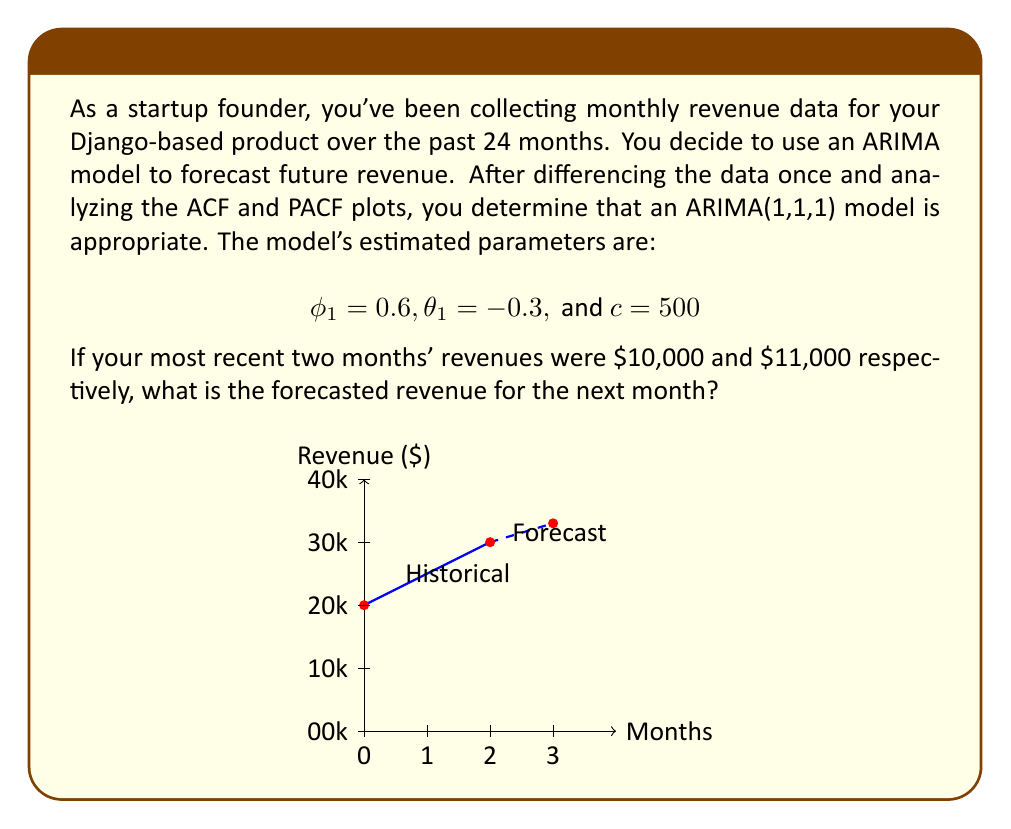Teach me how to tackle this problem. Let's approach this step-by-step:

1) The general form of an ARIMA(1,1,1) model is:

   $$(1-\phi_1B)(1-B)y_t = c + (1+\theta_1B)\epsilon_t$$

   where $B$ is the backshift operator.

2) Expanding this, we get:

   $$y_t - y_{t-1} = c + \phi_1(y_{t-1} - y_{t-2}) + \epsilon_t + \theta_1\epsilon_{t-1}$$

3) Rearranging to isolate $y_t$:

   $$y_t = c + y_{t-1} + \phi_1(y_{t-1} - y_{t-2}) + \epsilon_t + \theta_1\epsilon_{t-1}$$

4) For forecasting, we set future error terms to their expected value of 0:

   $$\hat{y}_t = c + y_{t-1} + \phi_1(y_{t-1} - y_{t-2})$$

5) Substituting the given values:

   $$\hat{y}_t = 500 + 11000 + 0.6(11000 - 10000)$$

6) Calculating:

   $$\hat{y}_t = 500 + 11000 + 0.6(1000) = 11500 + 600 = 12100$$

Therefore, the forecasted revenue for the next month is $12,100.
Answer: $12,100 